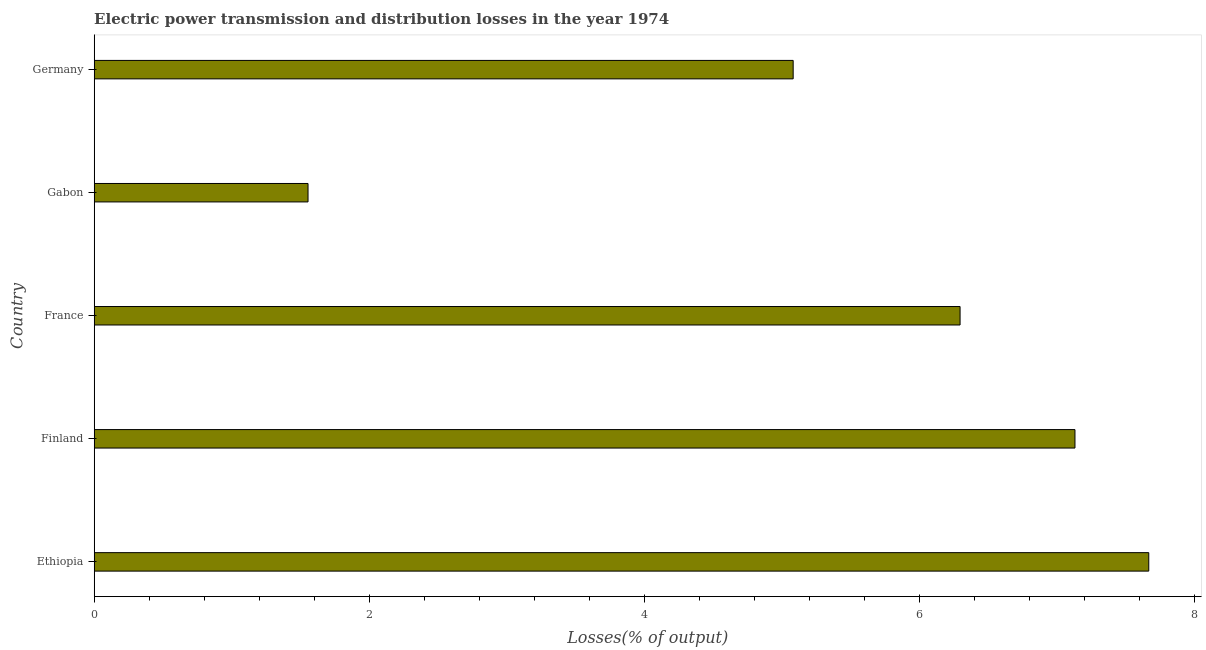Does the graph contain any zero values?
Keep it short and to the point. No. Does the graph contain grids?
Make the answer very short. No. What is the title of the graph?
Ensure brevity in your answer.  Electric power transmission and distribution losses in the year 1974. What is the label or title of the X-axis?
Provide a short and direct response. Losses(% of output). What is the label or title of the Y-axis?
Ensure brevity in your answer.  Country. What is the electric power transmission and distribution losses in Ethiopia?
Your answer should be very brief. 7.67. Across all countries, what is the maximum electric power transmission and distribution losses?
Offer a very short reply. 7.67. Across all countries, what is the minimum electric power transmission and distribution losses?
Your answer should be very brief. 1.55. In which country was the electric power transmission and distribution losses maximum?
Keep it short and to the point. Ethiopia. In which country was the electric power transmission and distribution losses minimum?
Ensure brevity in your answer.  Gabon. What is the sum of the electric power transmission and distribution losses?
Make the answer very short. 27.73. What is the difference between the electric power transmission and distribution losses in Ethiopia and Gabon?
Your answer should be compact. 6.11. What is the average electric power transmission and distribution losses per country?
Offer a terse response. 5.54. What is the median electric power transmission and distribution losses?
Ensure brevity in your answer.  6.29. In how many countries, is the electric power transmission and distribution losses greater than 2.4 %?
Ensure brevity in your answer.  4. What is the ratio of the electric power transmission and distribution losses in Finland to that in Gabon?
Provide a succinct answer. 4.59. Is the electric power transmission and distribution losses in Ethiopia less than that in Finland?
Keep it short and to the point. No. What is the difference between the highest and the second highest electric power transmission and distribution losses?
Ensure brevity in your answer.  0.54. What is the difference between the highest and the lowest electric power transmission and distribution losses?
Offer a very short reply. 6.11. In how many countries, is the electric power transmission and distribution losses greater than the average electric power transmission and distribution losses taken over all countries?
Offer a very short reply. 3. How many bars are there?
Provide a succinct answer. 5. How many countries are there in the graph?
Provide a succinct answer. 5. What is the Losses(% of output) of Ethiopia?
Ensure brevity in your answer.  7.67. What is the Losses(% of output) of Finland?
Give a very brief answer. 7.13. What is the Losses(% of output) in France?
Offer a terse response. 6.29. What is the Losses(% of output) in Gabon?
Your answer should be compact. 1.55. What is the Losses(% of output) of Germany?
Provide a short and direct response. 5.08. What is the difference between the Losses(% of output) in Ethiopia and Finland?
Your answer should be compact. 0.54. What is the difference between the Losses(% of output) in Ethiopia and France?
Your answer should be very brief. 1.37. What is the difference between the Losses(% of output) in Ethiopia and Gabon?
Give a very brief answer. 6.11. What is the difference between the Losses(% of output) in Ethiopia and Germany?
Ensure brevity in your answer.  2.58. What is the difference between the Losses(% of output) in Finland and France?
Your answer should be compact. 0.84. What is the difference between the Losses(% of output) in Finland and Gabon?
Your answer should be compact. 5.58. What is the difference between the Losses(% of output) in Finland and Germany?
Offer a terse response. 2.05. What is the difference between the Losses(% of output) in France and Gabon?
Give a very brief answer. 4.74. What is the difference between the Losses(% of output) in France and Germany?
Ensure brevity in your answer.  1.21. What is the difference between the Losses(% of output) in Gabon and Germany?
Offer a very short reply. -3.53. What is the ratio of the Losses(% of output) in Ethiopia to that in Finland?
Your answer should be very brief. 1.07. What is the ratio of the Losses(% of output) in Ethiopia to that in France?
Make the answer very short. 1.22. What is the ratio of the Losses(% of output) in Ethiopia to that in Gabon?
Provide a short and direct response. 4.93. What is the ratio of the Losses(% of output) in Ethiopia to that in Germany?
Ensure brevity in your answer.  1.51. What is the ratio of the Losses(% of output) in Finland to that in France?
Provide a succinct answer. 1.13. What is the ratio of the Losses(% of output) in Finland to that in Gabon?
Provide a short and direct response. 4.59. What is the ratio of the Losses(% of output) in Finland to that in Germany?
Provide a short and direct response. 1.4. What is the ratio of the Losses(% of output) in France to that in Gabon?
Your response must be concise. 4.05. What is the ratio of the Losses(% of output) in France to that in Germany?
Give a very brief answer. 1.24. What is the ratio of the Losses(% of output) in Gabon to that in Germany?
Provide a succinct answer. 0.31. 